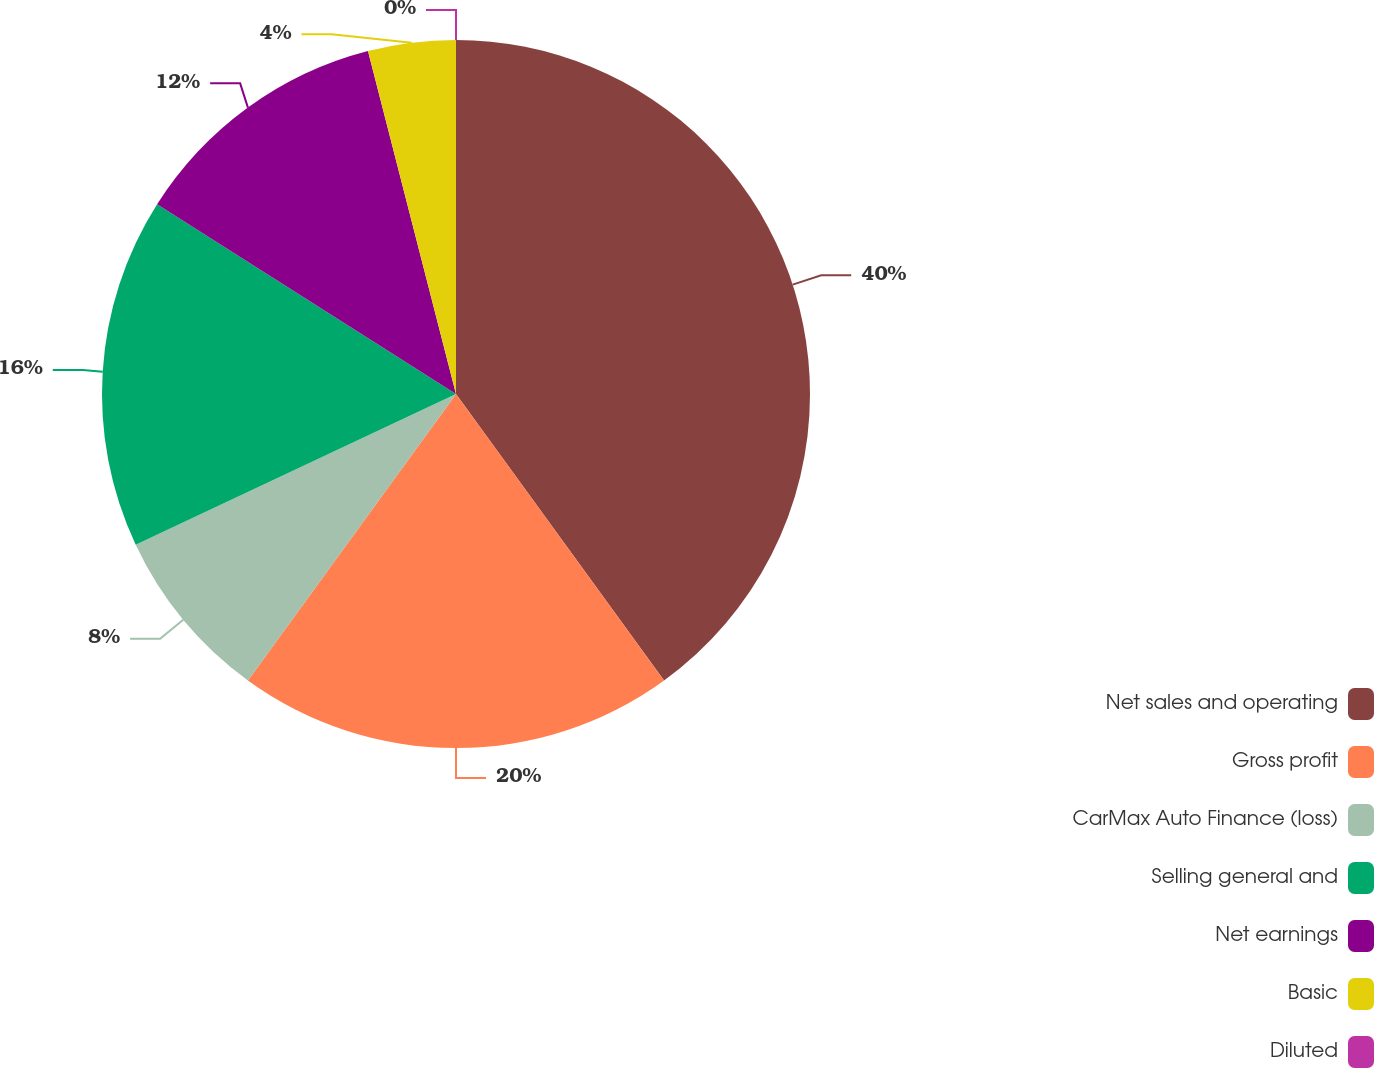Convert chart. <chart><loc_0><loc_0><loc_500><loc_500><pie_chart><fcel>Net sales and operating<fcel>Gross profit<fcel>CarMax Auto Finance (loss)<fcel>Selling general and<fcel>Net earnings<fcel>Basic<fcel>Diluted<nl><fcel>40.0%<fcel>20.0%<fcel>8.0%<fcel>16.0%<fcel>12.0%<fcel>4.0%<fcel>0.0%<nl></chart> 